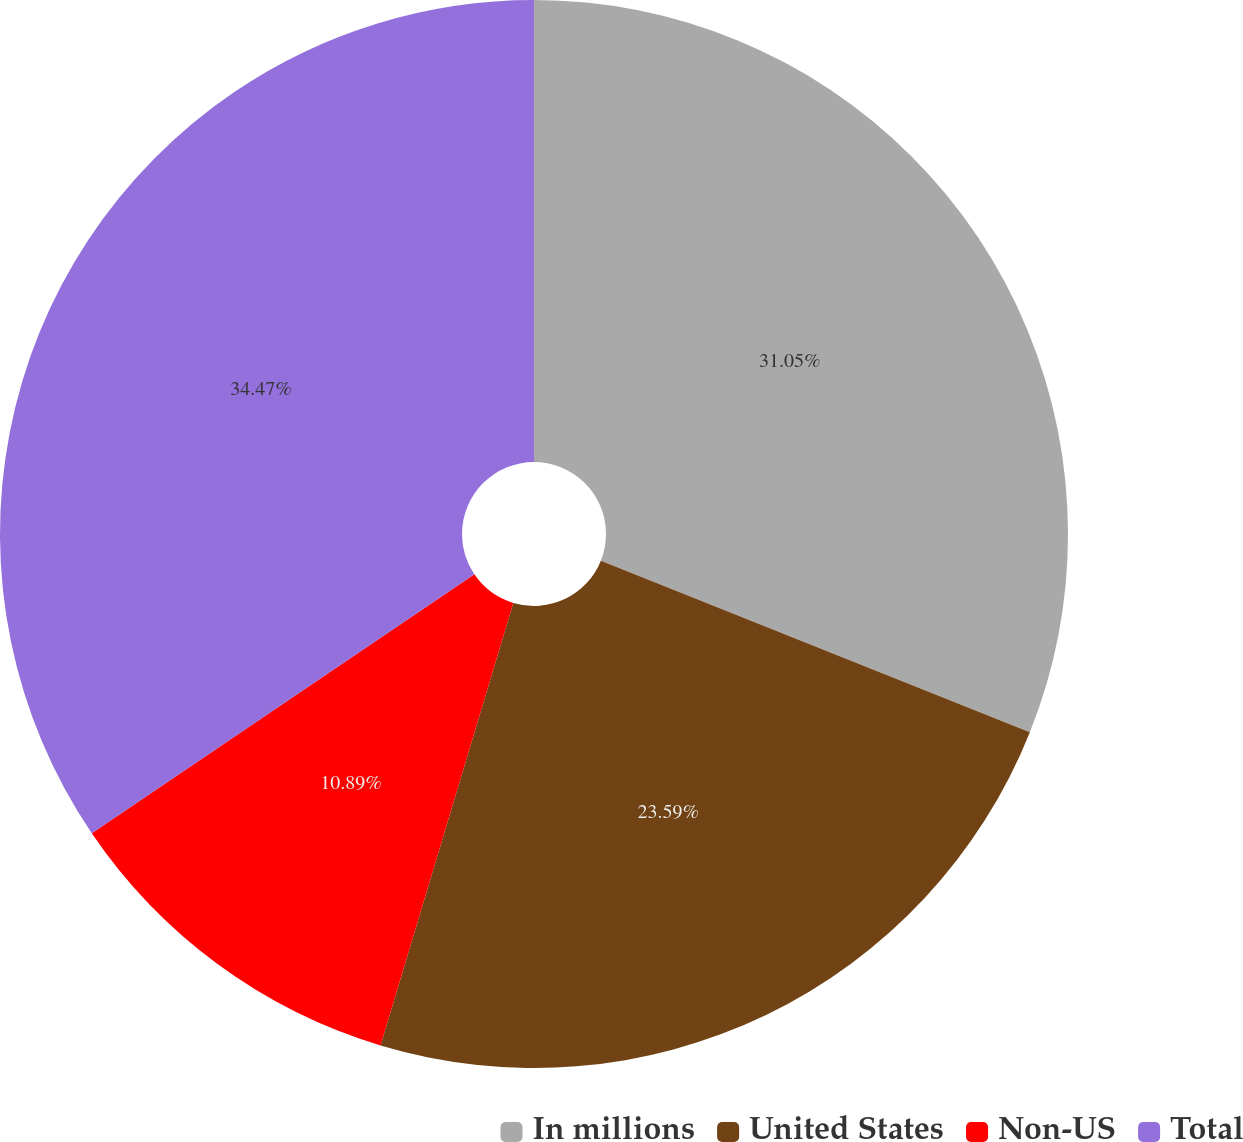Convert chart to OTSL. <chart><loc_0><loc_0><loc_500><loc_500><pie_chart><fcel>In millions<fcel>United States<fcel>Non-US<fcel>Total<nl><fcel>31.05%<fcel>23.59%<fcel>10.89%<fcel>34.47%<nl></chart> 